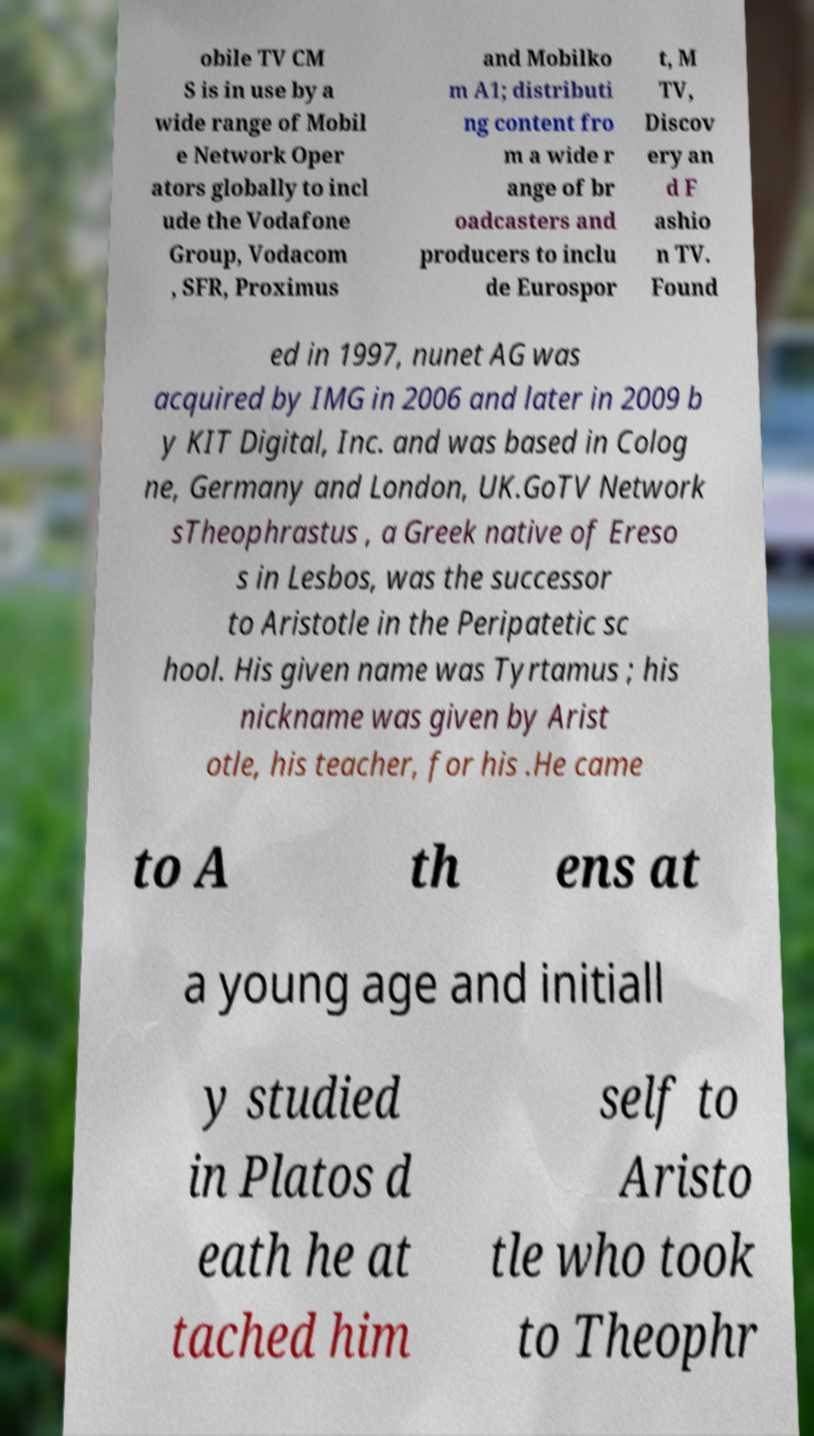Could you assist in decoding the text presented in this image and type it out clearly? obile TV CM S is in use by a wide range of Mobil e Network Oper ators globally to incl ude the Vodafone Group, Vodacom , SFR, Proximus and Mobilko m A1; distributi ng content fro m a wide r ange of br oadcasters and producers to inclu de Eurospor t, M TV, Discov ery an d F ashio n TV. Found ed in 1997, nunet AG was acquired by IMG in 2006 and later in 2009 b y KIT Digital, Inc. and was based in Colog ne, Germany and London, UK.GoTV Network sTheophrastus , a Greek native of Ereso s in Lesbos, was the successor to Aristotle in the Peripatetic sc hool. His given name was Tyrtamus ; his nickname was given by Arist otle, his teacher, for his .He came to A th ens at a young age and initiall y studied in Platos d eath he at tached him self to Aristo tle who took to Theophr 